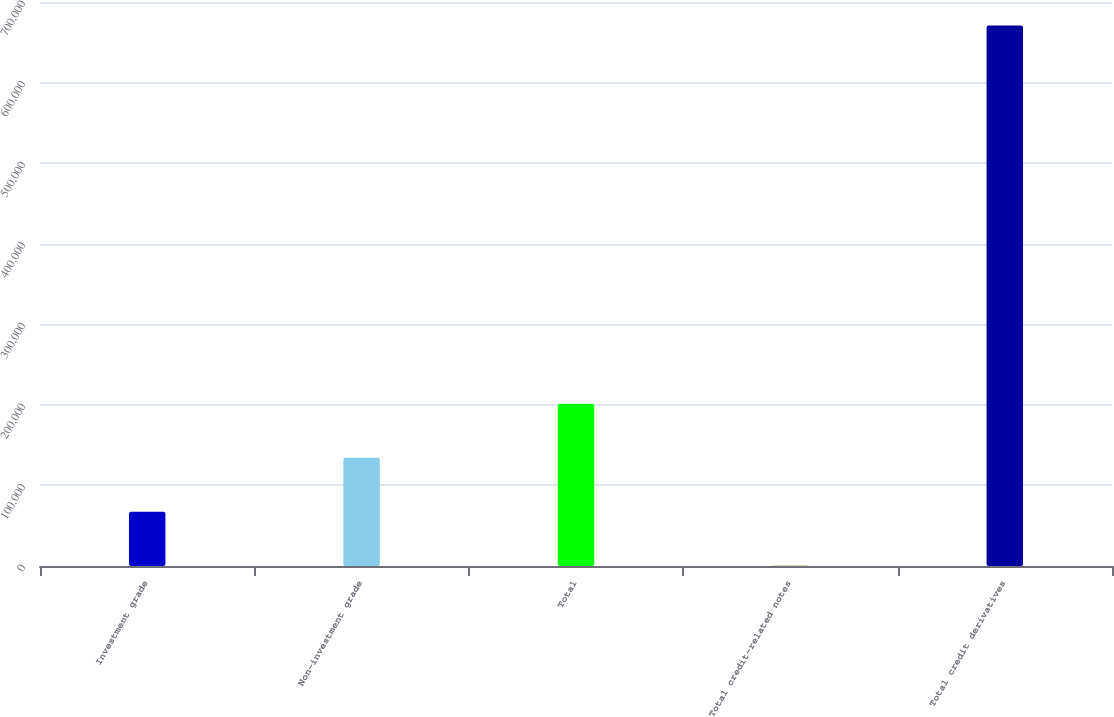Convert chart to OTSL. <chart><loc_0><loc_0><loc_500><loc_500><bar_chart><fcel>Investment grade<fcel>Non-investment grade<fcel>Total<fcel>Total credit-related notes<fcel>Total credit derivatives<nl><fcel>67252.5<fcel>134331<fcel>201410<fcel>174<fcel>670959<nl></chart> 